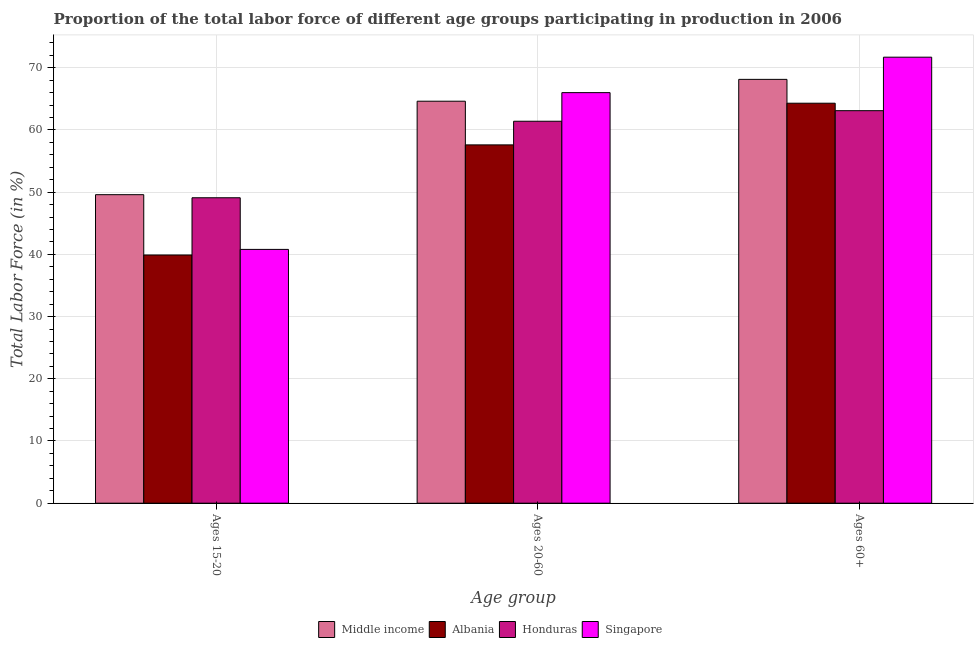How many bars are there on the 2nd tick from the right?
Offer a very short reply. 4. What is the label of the 2nd group of bars from the left?
Offer a very short reply. Ages 20-60. What is the percentage of labor force within the age group 20-60 in Albania?
Keep it short and to the point. 57.6. Across all countries, what is the maximum percentage of labor force within the age group 20-60?
Keep it short and to the point. 66. Across all countries, what is the minimum percentage of labor force within the age group 15-20?
Ensure brevity in your answer.  39.9. In which country was the percentage of labor force above age 60 maximum?
Provide a short and direct response. Singapore. In which country was the percentage of labor force within the age group 20-60 minimum?
Your response must be concise. Albania. What is the total percentage of labor force within the age group 20-60 in the graph?
Offer a terse response. 249.62. What is the difference between the percentage of labor force above age 60 in Albania and that in Honduras?
Make the answer very short. 1.2. What is the difference between the percentage of labor force above age 60 in Singapore and the percentage of labor force within the age group 20-60 in Middle income?
Give a very brief answer. 7.08. What is the average percentage of labor force above age 60 per country?
Your answer should be very brief. 66.81. What is the difference between the percentage of labor force within the age group 15-20 and percentage of labor force within the age group 20-60 in Albania?
Offer a terse response. -17.7. What is the ratio of the percentage of labor force above age 60 in Singapore to that in Honduras?
Provide a short and direct response. 1.14. Is the percentage of labor force within the age group 15-20 in Middle income less than that in Honduras?
Provide a short and direct response. No. Is the difference between the percentage of labor force above age 60 in Singapore and Honduras greater than the difference between the percentage of labor force within the age group 15-20 in Singapore and Honduras?
Offer a very short reply. Yes. What is the difference between the highest and the second highest percentage of labor force within the age group 20-60?
Your response must be concise. 1.38. What is the difference between the highest and the lowest percentage of labor force within the age group 15-20?
Provide a short and direct response. 9.7. In how many countries, is the percentage of labor force within the age group 15-20 greater than the average percentage of labor force within the age group 15-20 taken over all countries?
Offer a terse response. 2. What does the 3rd bar from the left in Ages 60+ represents?
Your answer should be compact. Honduras. What does the 1st bar from the right in Ages 15-20 represents?
Your response must be concise. Singapore. Is it the case that in every country, the sum of the percentage of labor force within the age group 15-20 and percentage of labor force within the age group 20-60 is greater than the percentage of labor force above age 60?
Make the answer very short. Yes. Where does the legend appear in the graph?
Offer a very short reply. Bottom center. What is the title of the graph?
Give a very brief answer. Proportion of the total labor force of different age groups participating in production in 2006. Does "Puerto Rico" appear as one of the legend labels in the graph?
Keep it short and to the point. No. What is the label or title of the X-axis?
Make the answer very short. Age group. What is the label or title of the Y-axis?
Make the answer very short. Total Labor Force (in %). What is the Total Labor Force (in %) in Middle income in Ages 15-20?
Your answer should be very brief. 49.6. What is the Total Labor Force (in %) of Albania in Ages 15-20?
Make the answer very short. 39.9. What is the Total Labor Force (in %) in Honduras in Ages 15-20?
Your answer should be compact. 49.1. What is the Total Labor Force (in %) of Singapore in Ages 15-20?
Offer a very short reply. 40.8. What is the Total Labor Force (in %) in Middle income in Ages 20-60?
Ensure brevity in your answer.  64.62. What is the Total Labor Force (in %) of Albania in Ages 20-60?
Provide a short and direct response. 57.6. What is the Total Labor Force (in %) in Honduras in Ages 20-60?
Your answer should be compact. 61.4. What is the Total Labor Force (in %) of Singapore in Ages 20-60?
Your answer should be compact. 66. What is the Total Labor Force (in %) of Middle income in Ages 60+?
Give a very brief answer. 68.13. What is the Total Labor Force (in %) in Albania in Ages 60+?
Your answer should be compact. 64.3. What is the Total Labor Force (in %) in Honduras in Ages 60+?
Offer a terse response. 63.1. What is the Total Labor Force (in %) of Singapore in Ages 60+?
Provide a short and direct response. 71.7. Across all Age group, what is the maximum Total Labor Force (in %) in Middle income?
Offer a very short reply. 68.13. Across all Age group, what is the maximum Total Labor Force (in %) of Albania?
Keep it short and to the point. 64.3. Across all Age group, what is the maximum Total Labor Force (in %) in Honduras?
Offer a very short reply. 63.1. Across all Age group, what is the maximum Total Labor Force (in %) in Singapore?
Your response must be concise. 71.7. Across all Age group, what is the minimum Total Labor Force (in %) of Middle income?
Provide a short and direct response. 49.6. Across all Age group, what is the minimum Total Labor Force (in %) in Albania?
Keep it short and to the point. 39.9. Across all Age group, what is the minimum Total Labor Force (in %) of Honduras?
Your answer should be very brief. 49.1. Across all Age group, what is the minimum Total Labor Force (in %) of Singapore?
Ensure brevity in your answer.  40.8. What is the total Total Labor Force (in %) of Middle income in the graph?
Your answer should be very brief. 182.35. What is the total Total Labor Force (in %) of Albania in the graph?
Give a very brief answer. 161.8. What is the total Total Labor Force (in %) in Honduras in the graph?
Your answer should be compact. 173.6. What is the total Total Labor Force (in %) in Singapore in the graph?
Keep it short and to the point. 178.5. What is the difference between the Total Labor Force (in %) in Middle income in Ages 15-20 and that in Ages 20-60?
Your answer should be very brief. -15.03. What is the difference between the Total Labor Force (in %) in Albania in Ages 15-20 and that in Ages 20-60?
Offer a terse response. -17.7. What is the difference between the Total Labor Force (in %) in Honduras in Ages 15-20 and that in Ages 20-60?
Ensure brevity in your answer.  -12.3. What is the difference between the Total Labor Force (in %) in Singapore in Ages 15-20 and that in Ages 20-60?
Provide a short and direct response. -25.2. What is the difference between the Total Labor Force (in %) of Middle income in Ages 15-20 and that in Ages 60+?
Provide a succinct answer. -18.54. What is the difference between the Total Labor Force (in %) in Albania in Ages 15-20 and that in Ages 60+?
Your answer should be compact. -24.4. What is the difference between the Total Labor Force (in %) in Honduras in Ages 15-20 and that in Ages 60+?
Your answer should be compact. -14. What is the difference between the Total Labor Force (in %) of Singapore in Ages 15-20 and that in Ages 60+?
Offer a terse response. -30.9. What is the difference between the Total Labor Force (in %) in Middle income in Ages 20-60 and that in Ages 60+?
Your response must be concise. -3.51. What is the difference between the Total Labor Force (in %) of Middle income in Ages 15-20 and the Total Labor Force (in %) of Albania in Ages 20-60?
Make the answer very short. -8. What is the difference between the Total Labor Force (in %) in Middle income in Ages 15-20 and the Total Labor Force (in %) in Honduras in Ages 20-60?
Give a very brief answer. -11.8. What is the difference between the Total Labor Force (in %) of Middle income in Ages 15-20 and the Total Labor Force (in %) of Singapore in Ages 20-60?
Offer a very short reply. -16.4. What is the difference between the Total Labor Force (in %) in Albania in Ages 15-20 and the Total Labor Force (in %) in Honduras in Ages 20-60?
Offer a very short reply. -21.5. What is the difference between the Total Labor Force (in %) of Albania in Ages 15-20 and the Total Labor Force (in %) of Singapore in Ages 20-60?
Your answer should be compact. -26.1. What is the difference between the Total Labor Force (in %) in Honduras in Ages 15-20 and the Total Labor Force (in %) in Singapore in Ages 20-60?
Give a very brief answer. -16.9. What is the difference between the Total Labor Force (in %) in Middle income in Ages 15-20 and the Total Labor Force (in %) in Albania in Ages 60+?
Ensure brevity in your answer.  -14.7. What is the difference between the Total Labor Force (in %) in Middle income in Ages 15-20 and the Total Labor Force (in %) in Honduras in Ages 60+?
Offer a very short reply. -13.5. What is the difference between the Total Labor Force (in %) in Middle income in Ages 15-20 and the Total Labor Force (in %) in Singapore in Ages 60+?
Your response must be concise. -22.1. What is the difference between the Total Labor Force (in %) of Albania in Ages 15-20 and the Total Labor Force (in %) of Honduras in Ages 60+?
Your answer should be very brief. -23.2. What is the difference between the Total Labor Force (in %) of Albania in Ages 15-20 and the Total Labor Force (in %) of Singapore in Ages 60+?
Provide a succinct answer. -31.8. What is the difference between the Total Labor Force (in %) in Honduras in Ages 15-20 and the Total Labor Force (in %) in Singapore in Ages 60+?
Make the answer very short. -22.6. What is the difference between the Total Labor Force (in %) of Middle income in Ages 20-60 and the Total Labor Force (in %) of Albania in Ages 60+?
Your answer should be compact. 0.32. What is the difference between the Total Labor Force (in %) in Middle income in Ages 20-60 and the Total Labor Force (in %) in Honduras in Ages 60+?
Provide a succinct answer. 1.52. What is the difference between the Total Labor Force (in %) in Middle income in Ages 20-60 and the Total Labor Force (in %) in Singapore in Ages 60+?
Keep it short and to the point. -7.08. What is the difference between the Total Labor Force (in %) of Albania in Ages 20-60 and the Total Labor Force (in %) of Honduras in Ages 60+?
Provide a short and direct response. -5.5. What is the difference between the Total Labor Force (in %) in Albania in Ages 20-60 and the Total Labor Force (in %) in Singapore in Ages 60+?
Offer a very short reply. -14.1. What is the average Total Labor Force (in %) in Middle income per Age group?
Keep it short and to the point. 60.78. What is the average Total Labor Force (in %) of Albania per Age group?
Make the answer very short. 53.93. What is the average Total Labor Force (in %) of Honduras per Age group?
Offer a terse response. 57.87. What is the average Total Labor Force (in %) in Singapore per Age group?
Keep it short and to the point. 59.5. What is the difference between the Total Labor Force (in %) of Middle income and Total Labor Force (in %) of Albania in Ages 15-20?
Make the answer very short. 9.7. What is the difference between the Total Labor Force (in %) of Middle income and Total Labor Force (in %) of Honduras in Ages 15-20?
Your response must be concise. 0.5. What is the difference between the Total Labor Force (in %) in Middle income and Total Labor Force (in %) in Singapore in Ages 15-20?
Provide a short and direct response. 8.8. What is the difference between the Total Labor Force (in %) in Middle income and Total Labor Force (in %) in Albania in Ages 20-60?
Your answer should be compact. 7.02. What is the difference between the Total Labor Force (in %) in Middle income and Total Labor Force (in %) in Honduras in Ages 20-60?
Provide a short and direct response. 3.22. What is the difference between the Total Labor Force (in %) in Middle income and Total Labor Force (in %) in Singapore in Ages 20-60?
Ensure brevity in your answer.  -1.38. What is the difference between the Total Labor Force (in %) in Albania and Total Labor Force (in %) in Honduras in Ages 20-60?
Keep it short and to the point. -3.8. What is the difference between the Total Labor Force (in %) in Albania and Total Labor Force (in %) in Singapore in Ages 20-60?
Provide a succinct answer. -8.4. What is the difference between the Total Labor Force (in %) of Honduras and Total Labor Force (in %) of Singapore in Ages 20-60?
Your answer should be very brief. -4.6. What is the difference between the Total Labor Force (in %) in Middle income and Total Labor Force (in %) in Albania in Ages 60+?
Provide a short and direct response. 3.83. What is the difference between the Total Labor Force (in %) in Middle income and Total Labor Force (in %) in Honduras in Ages 60+?
Give a very brief answer. 5.03. What is the difference between the Total Labor Force (in %) in Middle income and Total Labor Force (in %) in Singapore in Ages 60+?
Make the answer very short. -3.57. What is the difference between the Total Labor Force (in %) in Albania and Total Labor Force (in %) in Honduras in Ages 60+?
Your response must be concise. 1.2. What is the difference between the Total Labor Force (in %) in Albania and Total Labor Force (in %) in Singapore in Ages 60+?
Give a very brief answer. -7.4. What is the difference between the Total Labor Force (in %) in Honduras and Total Labor Force (in %) in Singapore in Ages 60+?
Your answer should be compact. -8.6. What is the ratio of the Total Labor Force (in %) in Middle income in Ages 15-20 to that in Ages 20-60?
Make the answer very short. 0.77. What is the ratio of the Total Labor Force (in %) in Albania in Ages 15-20 to that in Ages 20-60?
Offer a very short reply. 0.69. What is the ratio of the Total Labor Force (in %) of Honduras in Ages 15-20 to that in Ages 20-60?
Offer a very short reply. 0.8. What is the ratio of the Total Labor Force (in %) of Singapore in Ages 15-20 to that in Ages 20-60?
Provide a succinct answer. 0.62. What is the ratio of the Total Labor Force (in %) in Middle income in Ages 15-20 to that in Ages 60+?
Offer a terse response. 0.73. What is the ratio of the Total Labor Force (in %) of Albania in Ages 15-20 to that in Ages 60+?
Your response must be concise. 0.62. What is the ratio of the Total Labor Force (in %) in Honduras in Ages 15-20 to that in Ages 60+?
Provide a succinct answer. 0.78. What is the ratio of the Total Labor Force (in %) in Singapore in Ages 15-20 to that in Ages 60+?
Ensure brevity in your answer.  0.57. What is the ratio of the Total Labor Force (in %) in Middle income in Ages 20-60 to that in Ages 60+?
Your response must be concise. 0.95. What is the ratio of the Total Labor Force (in %) of Albania in Ages 20-60 to that in Ages 60+?
Provide a short and direct response. 0.9. What is the ratio of the Total Labor Force (in %) in Honduras in Ages 20-60 to that in Ages 60+?
Give a very brief answer. 0.97. What is the ratio of the Total Labor Force (in %) of Singapore in Ages 20-60 to that in Ages 60+?
Keep it short and to the point. 0.92. What is the difference between the highest and the second highest Total Labor Force (in %) in Middle income?
Offer a very short reply. 3.51. What is the difference between the highest and the second highest Total Labor Force (in %) in Albania?
Provide a short and direct response. 6.7. What is the difference between the highest and the second highest Total Labor Force (in %) of Singapore?
Keep it short and to the point. 5.7. What is the difference between the highest and the lowest Total Labor Force (in %) in Middle income?
Provide a succinct answer. 18.54. What is the difference between the highest and the lowest Total Labor Force (in %) of Albania?
Your response must be concise. 24.4. What is the difference between the highest and the lowest Total Labor Force (in %) in Singapore?
Your answer should be compact. 30.9. 